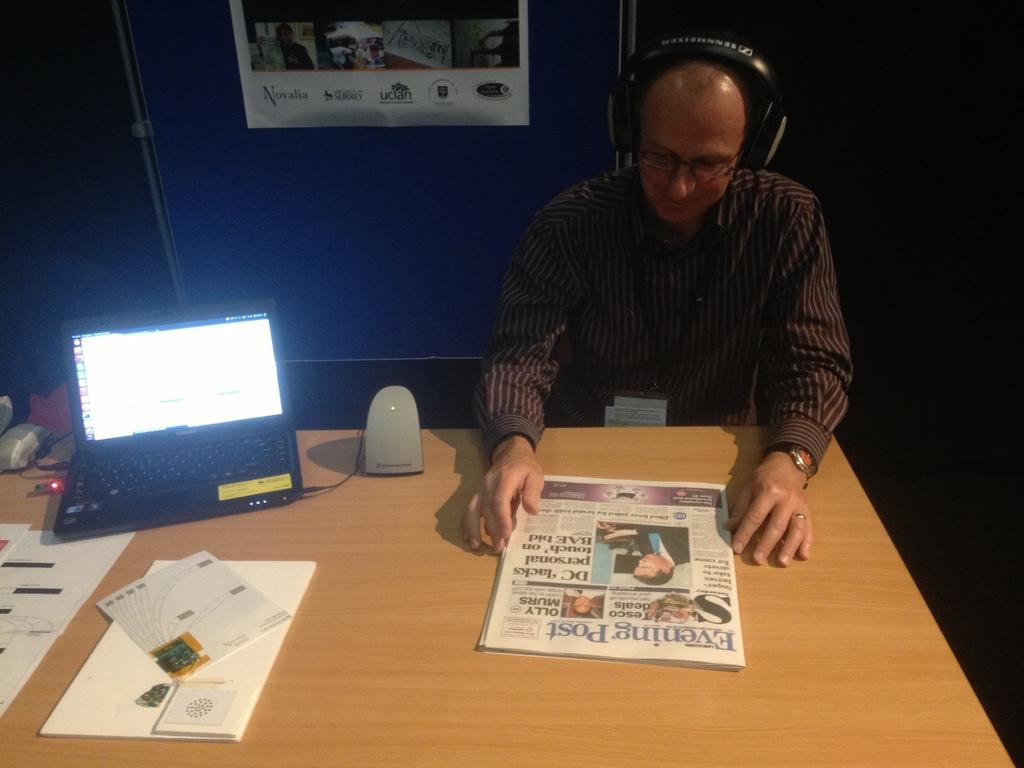<image>
Give a short and clear explanation of the subsequent image. A man sitting at a desk reading the Evening Post 